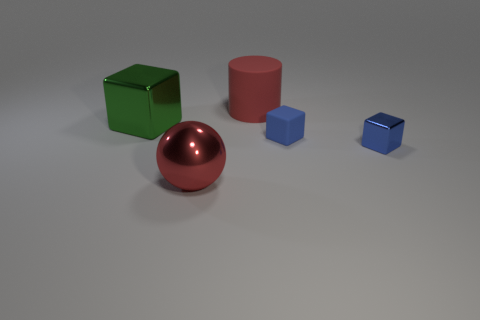There is a big red object that is in front of the big thing that is right of the large red shiny thing; what is its material? The big red object in question appears to be a cylinder made of a smooth, reflective material, likely metal, given its luster and the way it reflects light. 